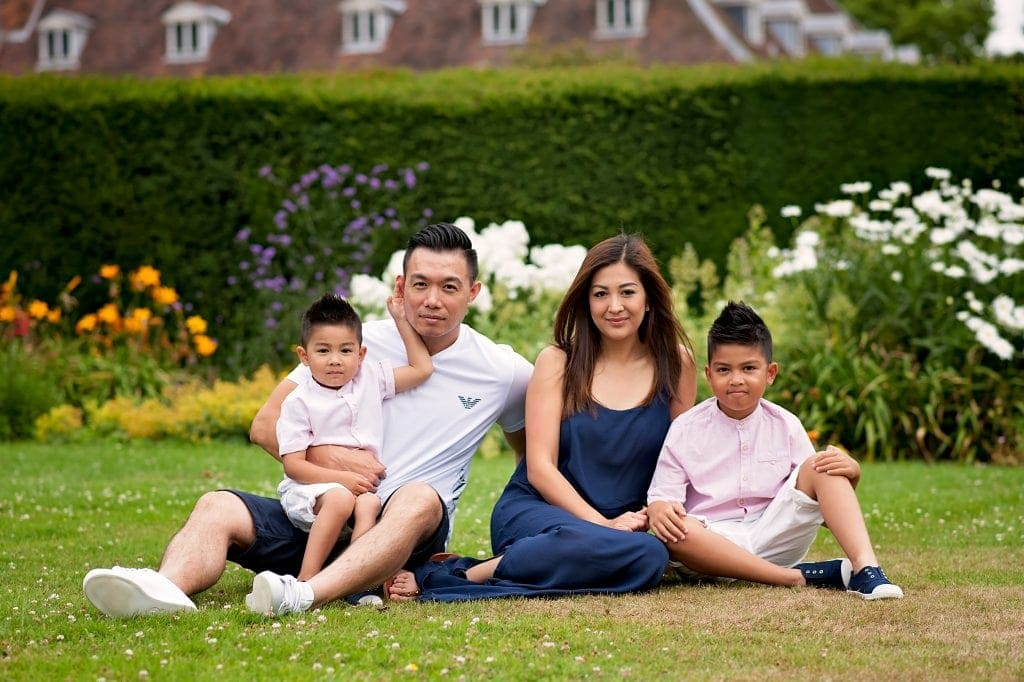What do you think was the family's main activity or purpose for gathering here? The main activity or purpose for the family's gathering in this serene garden seems to be to capture a family portrait or to enjoy a relaxing outing together. The carefully chosen, coordinated outfits and the posed yet relaxed seating arrangement suggest that they might be taking a commemorative photo, perhaps to mark a special occasion or simply to capture a moment of togetherness. The tranquil setting of the well-kept garden with blooming flowers and lush greenery provides a perfect backdrop for such a family photo session. If the family were to describe their bond in one word, what might it be and why? If the family were to describe their bond in one word, it might be ‘unbreakable.’ This is suggested by their close physical proximity, relaxed body language, and the protective and affectionate manner in which they interact with each other. The evident comfort in each other's presence and the genuine smiles indicate a resilient and strong emotional connection. How would the image change if it was taken during nighttime under the moonlight? If the image were taken during nighttime under the moonlight, it would present a completely different ambiance and mood. The soft, silvery glow of the moon would cast a serene and mystical light on the family, creating dramatic shadows and highlights. The garden's vibrant colors would be subdued, replaced by a palette of deeper, muted tones. The family’s expressions might appear more contemplative or intimate in the gentler illumination, fostering a sense of coziness and quiet togetherness. The background details would fade into the darkness, focusing all attention on the family, highlighting their bond in the enchanting light of the moon. Imagine the family is in a magical garden where each flower has a unique ability. What abilities do the flowers possess, and how do they affect the family? In the magical garden, each flower possesses unique abilities that create a wondrous experience for the family. The golden sunflowers can emit a warm, radiant light that keeps the surroundings perpetually in a golden hour, making every moment picture-perfect. The lilies have the ability to purify the air and bring a sense of tranquility, ensuring the family feels at peace. The roses can communicate with the family through gentle whispers, sharing stories of the garden’s history and offering wisdom. The tulips can produce melodies when caressed by the wind, creating a symphony that serenades the family throughout their visit. The daisies possess rejuvenating properties, making the family feel invigorated and youthful. This entrancing experience in the magical garden leaves the family more connected and joyous, their spirits lifted by the enchanting flora surrounding them. What might be a quick but touching moment shared between the family during their time here? A quick but touching moment shared between the family might be the younger child playfully draping a blooming daisy over his father's ear, causing everyone to laugh. As they share this simple, joyful act, the mother takes a candid photo, capturing the spontaneous love and happiness of the moment—a memory they will cherish forever. Describe a typical day for this family in detail. A typical day for this family begins with a bustling but joyful morning. The father prepares a hearty breakfast, while the mother assists the older child in getting ready for school. The younger child enjoys some playful moments with their pet dog in the yard. Once everyone is dressed and fed, they head off—father drops the kids at school while mother goes to work. The day progresses with the children engaged in learning and activities at school, while the parents attend their respective jobs. In the afternoon, the mother picks up the children and takes them to a nearby park where they play and unwind. As evening approaches, the family reconvenes at home for a warm dinner. They share stories of their day, bursting into laughter and enjoying each other's company. Post-dinner, the family spends time together doing an activity, such as playing a board game or watching a favorite TV show. Eventually, it's bedtime for the children, with parents tucking them in with goodnight kisses and bedtime stories. The day concludes with the parents having a moment to themselves, reflecting on their day and planning for tomorrow, feeling grateful for their happy, busy life. What might their dream vacation look like and why? Their dream vacation might be a trip to a tropical island where they can enjoy the sun, sand, and sea. They envision spending days building sandcastles with the children, snorkeling in crystal-clear waters to explore vibrant marine life, and taking boat tours to nearby islands. Evenings would be about savoring delicious seafood at beachside restaurants, participating in cultural activities or learning traditional dances, and watching enchanting sunsets. This vacation provides a perfect blend of relaxation and adventure, allowing the family to bond more closely while creating unforgettable memories. The tranquil beaches and exciting activities would offer the rejuvenation and quality time they cherish, making this their ideal getaway. 